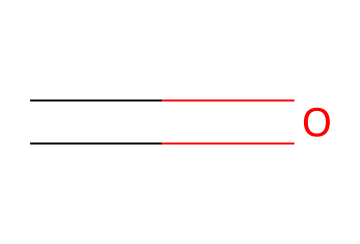What is the molecular formula of formaldehyde? The SMILES representation shows a carbon atom bonded to an oxygen atom with a double bond, indicating a single carbonyl group, which corresponds to the molecular formula CH2O.
Answer: CH2O How many carbon atoms are present in formaldehyde? The SMILES representation shows one carbon atom (C), which is the central atom in the structure of formaldehyde.
Answer: 1 What type of bond is present between carbon and oxygen in formaldehyde? The SMILES indicates a double bond (indicated by "=") between carbon (C) and oxygen (O), meaning that the bond type is a double bond.
Answer: double bond Is formaldehyde classified as an aldehyde? The structure contains a carbon atom bonded to a carbonyl group (C=O), which is characteristic of aldehydes; thus, it confirms that formaldehyde is indeed an aldehyde.
Answer: yes Why is formaldehyde considered a toxic chemical? Formaldehyde is known to be toxic due to its reactivity and potential to cause irritation and long-term health effects, particularly when inhaled or absorbed by the body.
Answer: toxicity What is the primary use of formaldehyde in artificial turf? Formaldehyde is often used in the production of resin binders for artificial turf materials, contributing to durability and stability.
Answer: resin binders What are the potential health risks of exposure to formaldehyde? Exposure to formaldehyde can lead to respiratory issues, irritation of the eyes and skin, and has been linked to certain cancers, making it hazardous to health.
Answer: respiratory issues 